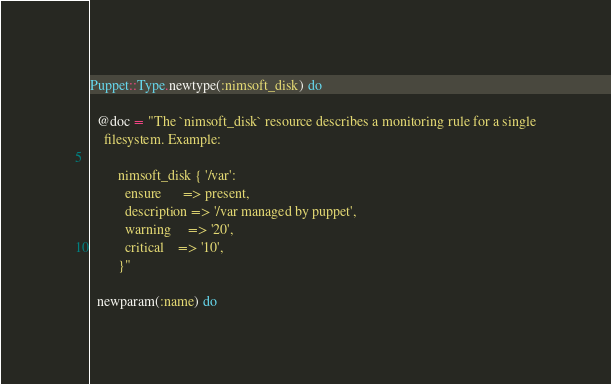<code> <loc_0><loc_0><loc_500><loc_500><_Ruby_>Puppet::Type.newtype(:nimsoft_disk) do

  @doc = "The `nimsoft_disk` resource describes a monitoring rule for a single
    filesystem. Example:

        nimsoft_disk { '/var':
          ensure      => present,
          description => '/var managed by puppet',
          warning     => '20',
          critical    => '10',
        }"

  newparam(:name) do</code> 